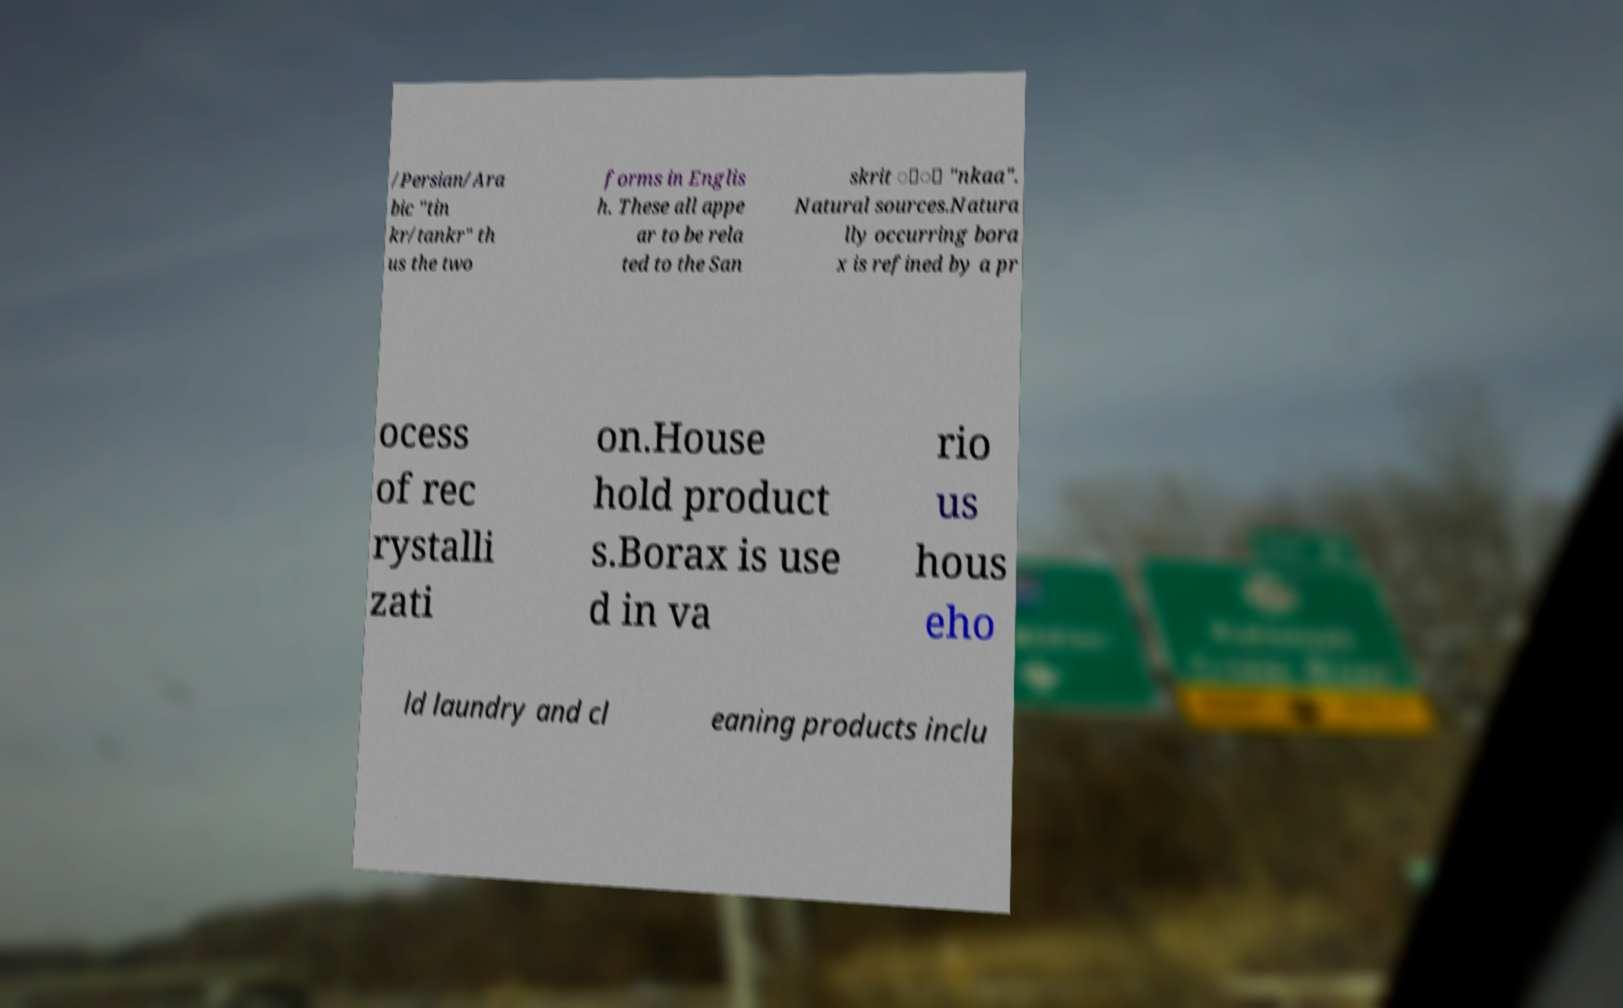Please identify and transcribe the text found in this image. /Persian/Ara bic "tin kr/tankr" th us the two forms in Englis h. These all appe ar to be rela ted to the San skrit ां "nkaa". Natural sources.Natura lly occurring bora x is refined by a pr ocess of rec rystalli zati on.House hold product s.Borax is use d in va rio us hous eho ld laundry and cl eaning products inclu 